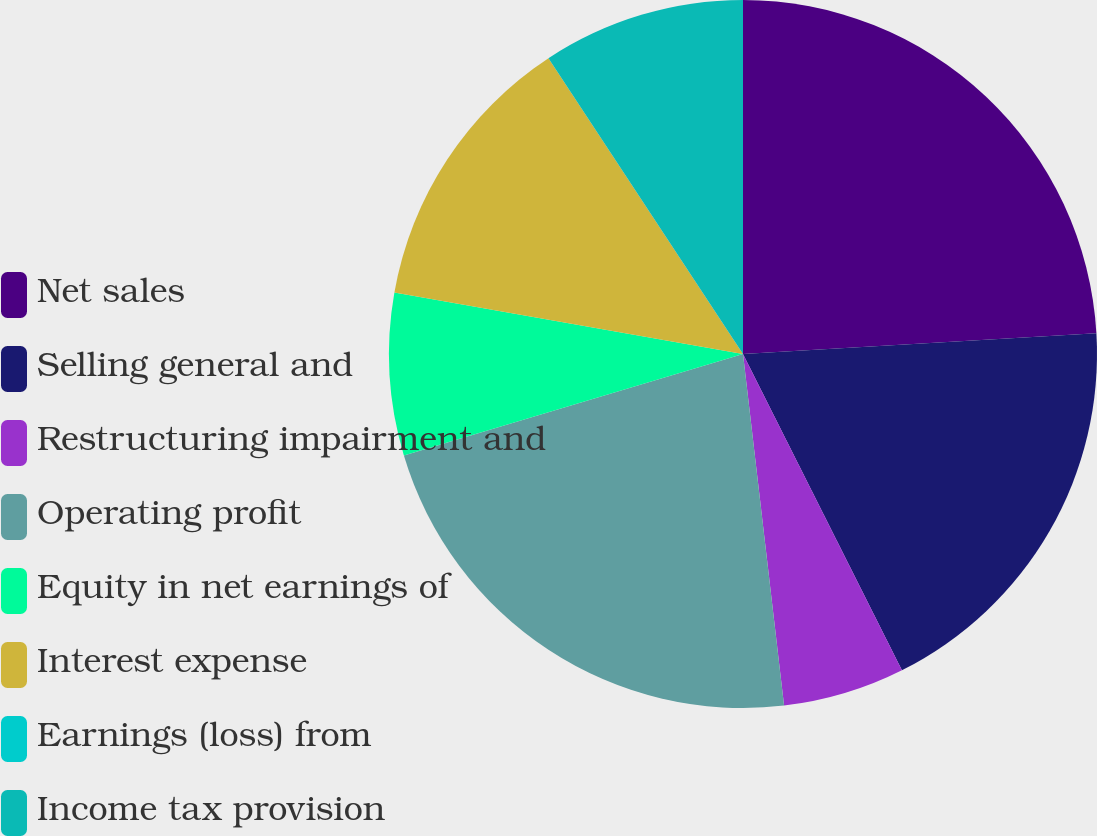<chart> <loc_0><loc_0><loc_500><loc_500><pie_chart><fcel>Net sales<fcel>Selling general and<fcel>Restructuring impairment and<fcel>Operating profit<fcel>Equity in net earnings of<fcel>Interest expense<fcel>Earnings (loss) from<fcel>Income tax provision<nl><fcel>24.07%<fcel>18.52%<fcel>5.56%<fcel>22.22%<fcel>7.41%<fcel>12.96%<fcel>0.0%<fcel>9.26%<nl></chart> 